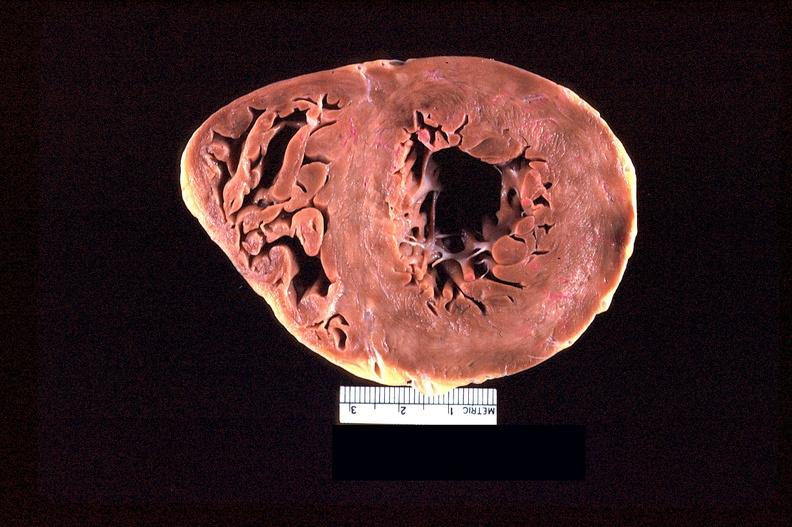what is present?
Answer the question using a single word or phrase. Cardiovascular 